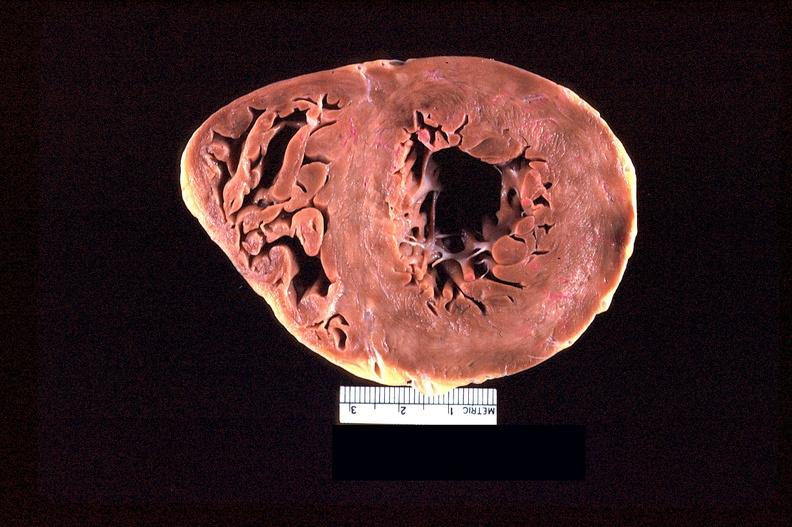what is present?
Answer the question using a single word or phrase. Cardiovascular 